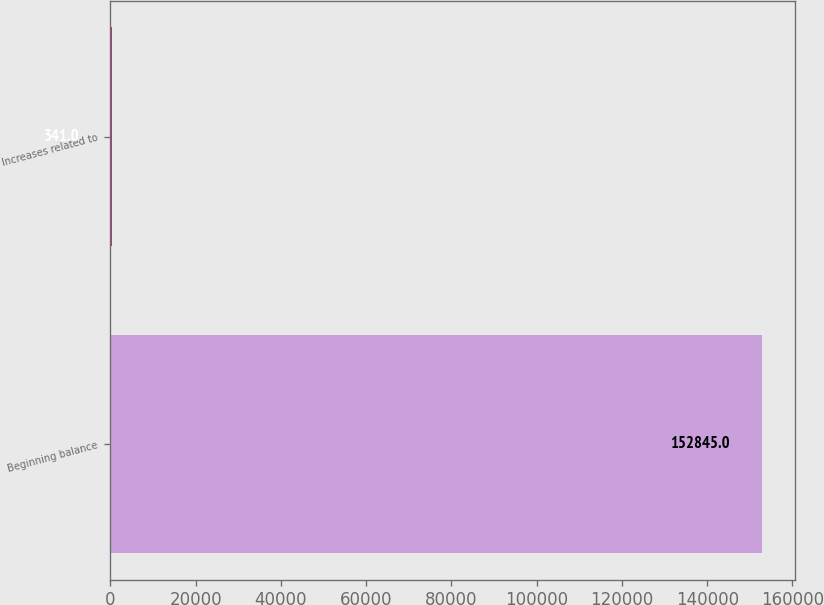<chart> <loc_0><loc_0><loc_500><loc_500><bar_chart><fcel>Beginning balance<fcel>Increases related to<nl><fcel>152845<fcel>341<nl></chart> 